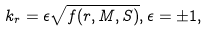<formula> <loc_0><loc_0><loc_500><loc_500>k _ { r } = \epsilon \sqrt { f ( r , M , S ) } , \epsilon = \pm 1 ,</formula> 